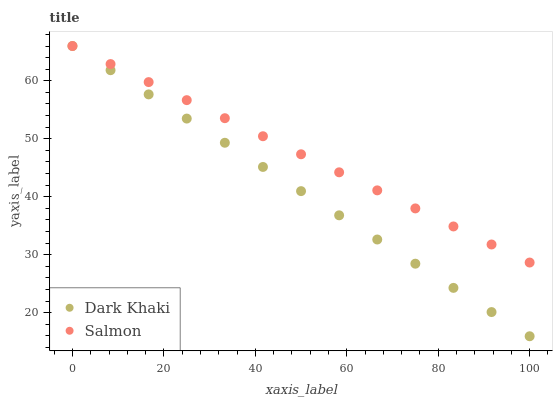Does Dark Khaki have the minimum area under the curve?
Answer yes or no. Yes. Does Salmon have the maximum area under the curve?
Answer yes or no. Yes. Does Salmon have the minimum area under the curve?
Answer yes or no. No. Is Dark Khaki the smoothest?
Answer yes or no. Yes. Is Salmon the roughest?
Answer yes or no. Yes. Is Salmon the smoothest?
Answer yes or no. No. Does Dark Khaki have the lowest value?
Answer yes or no. Yes. Does Salmon have the lowest value?
Answer yes or no. No. Does Salmon have the highest value?
Answer yes or no. Yes. Does Salmon intersect Dark Khaki?
Answer yes or no. Yes. Is Salmon less than Dark Khaki?
Answer yes or no. No. Is Salmon greater than Dark Khaki?
Answer yes or no. No. 